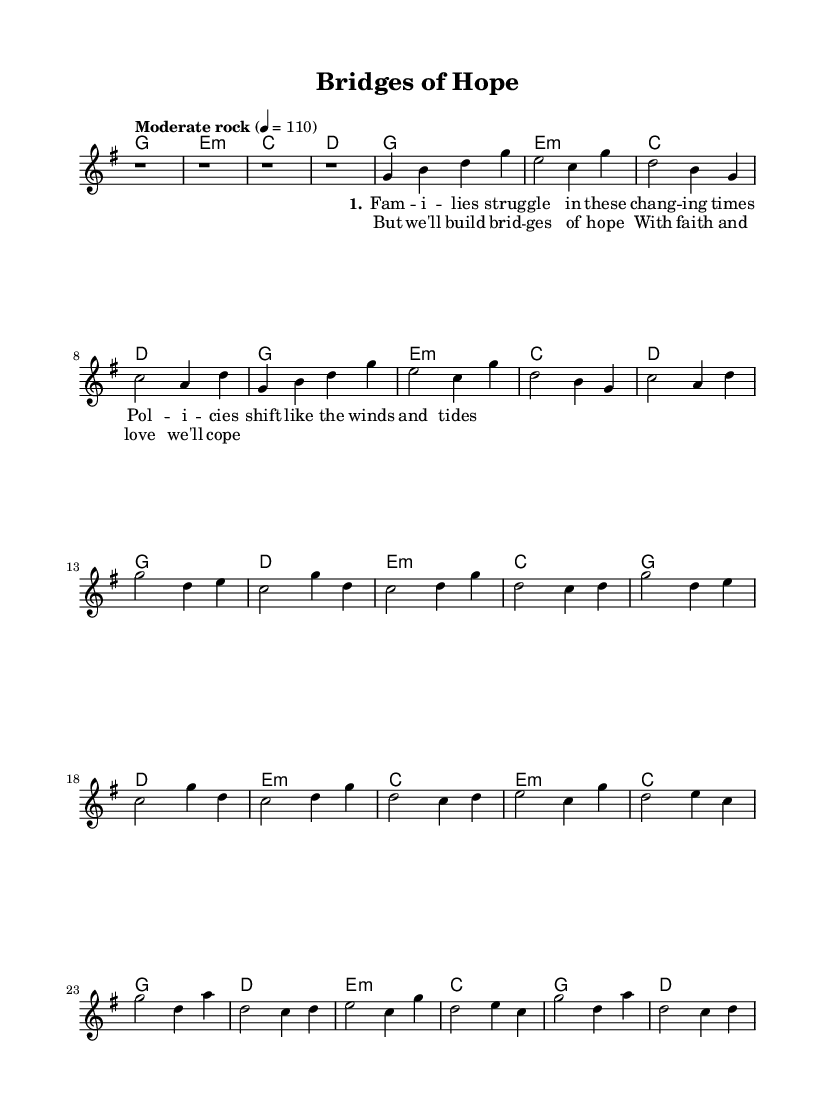What is the key signature of this music? The key signature is G major, which has one sharp (F#).
Answer: G major What is the time signature of this music? The time signature is 4/4, indicating four beats in each measure.
Answer: 4/4 What is the tempo marking given in the music? The tempo marking is "Moderate rock" with a metronome value of 110 beats per minute.
Answer: Moderate rock How many verses are present in this sheet music? There is one verse indicated in the lyrics section of the score.
Answer: 1 What is the first chord in the harmony section? The first chord is G major, which is the starting point of the piece.
Answer: G What does the chorus express in terms of themes? The chorus expresses themes of hope and resilience in the face of adversity, emphasizing a communal approach.
Answer: Hope and resilience How many times is the phrase "But we'll build bridges of hope" repeated? The phrase appears twice in the chorus, following the structure of the song.
Answer: 2 